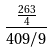Convert formula to latex. <formula><loc_0><loc_0><loc_500><loc_500>\frac { \frac { 2 6 3 } { 4 } } { 4 0 9 / 9 }</formula> 